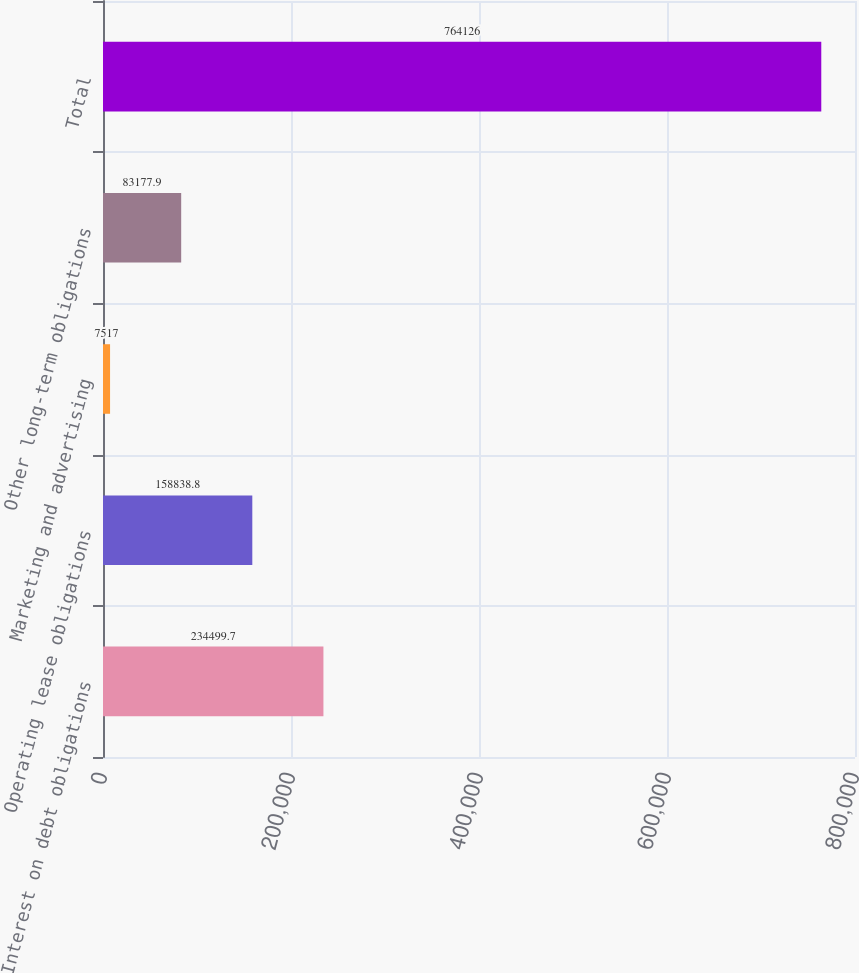Convert chart to OTSL. <chart><loc_0><loc_0><loc_500><loc_500><bar_chart><fcel>Interest on debt obligations<fcel>Operating lease obligations<fcel>Marketing and advertising<fcel>Other long-term obligations<fcel>Total<nl><fcel>234500<fcel>158839<fcel>7517<fcel>83177.9<fcel>764126<nl></chart> 